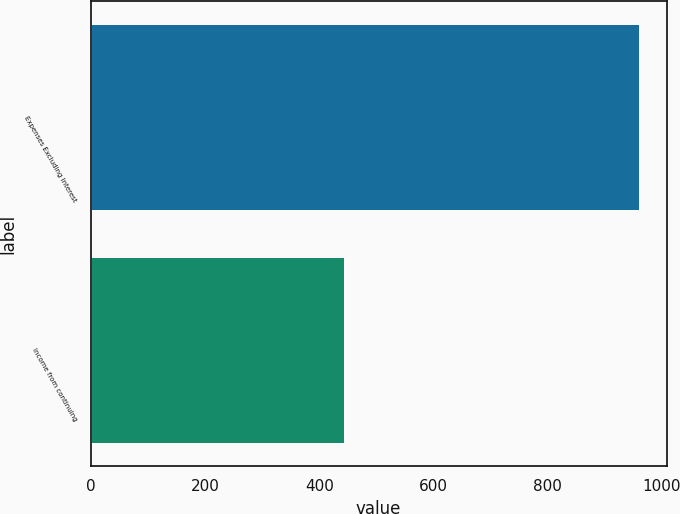Convert chart to OTSL. <chart><loc_0><loc_0><loc_500><loc_500><bar_chart><fcel>Expenses Excluding Interest<fcel>Income from continuing<nl><fcel>960<fcel>443<nl></chart> 